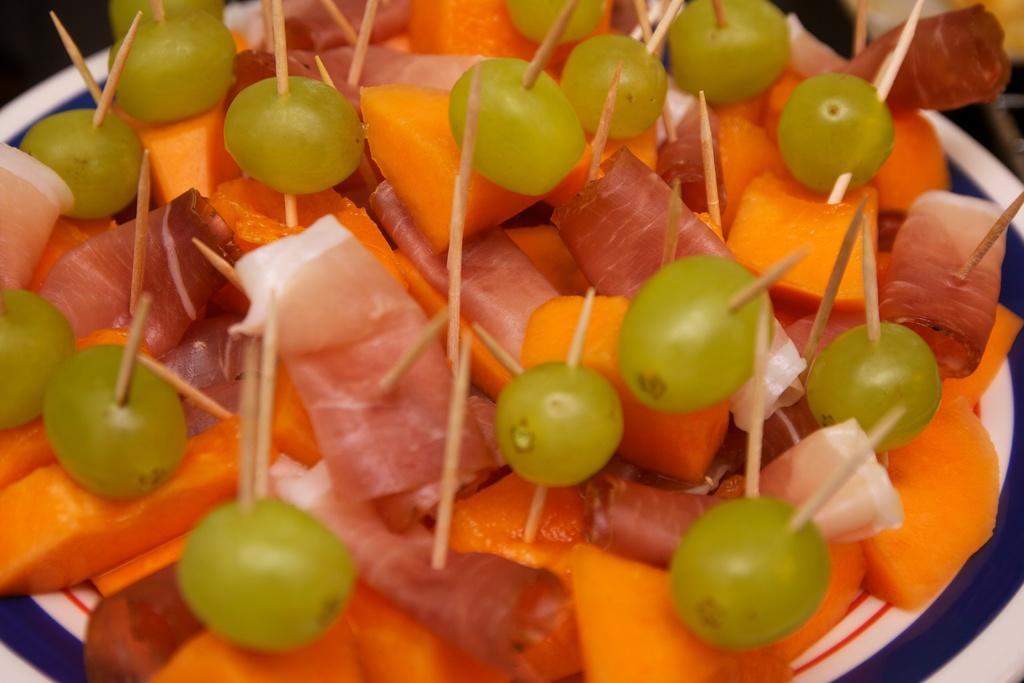Can you describe this image briefly? In this image, we can see fruits and flesh with sticks are on the plate. 